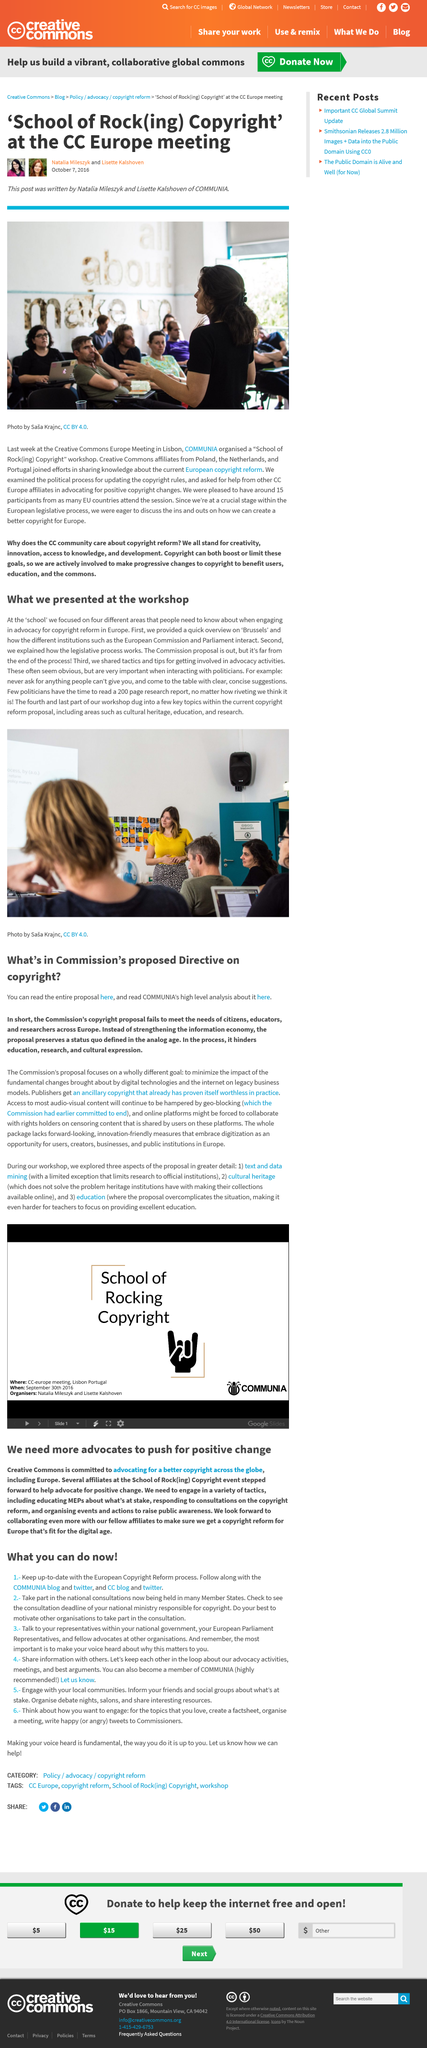Give some essential details in this illustration. The workshop focused on four distinct areas. The research report mentioned in the article was 200 pages long. There were 15 participants at the meeting. Yes, Creative Commons needs more advocates to push for positive change in copyright reform. The speaker in the workshop is wearing a yellow top. 